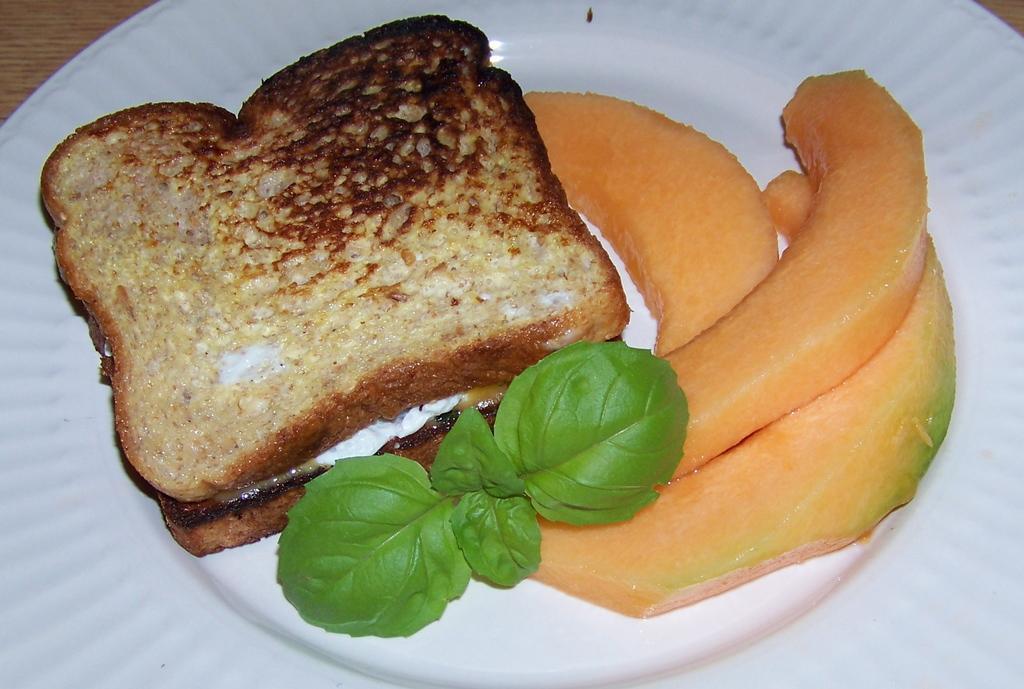In one or two sentences, can you explain what this image depicts? In this image there is a table with a plate on it and on the plate there are two toasts, a mint leaf and melon slices. 